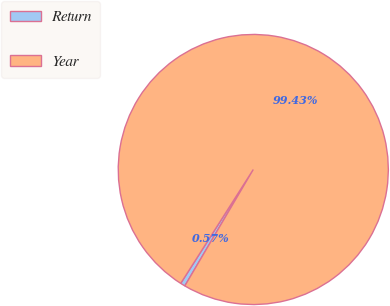Convert chart. <chart><loc_0><loc_0><loc_500><loc_500><pie_chart><fcel>Return<fcel>Year<nl><fcel>0.57%<fcel>99.43%<nl></chart> 